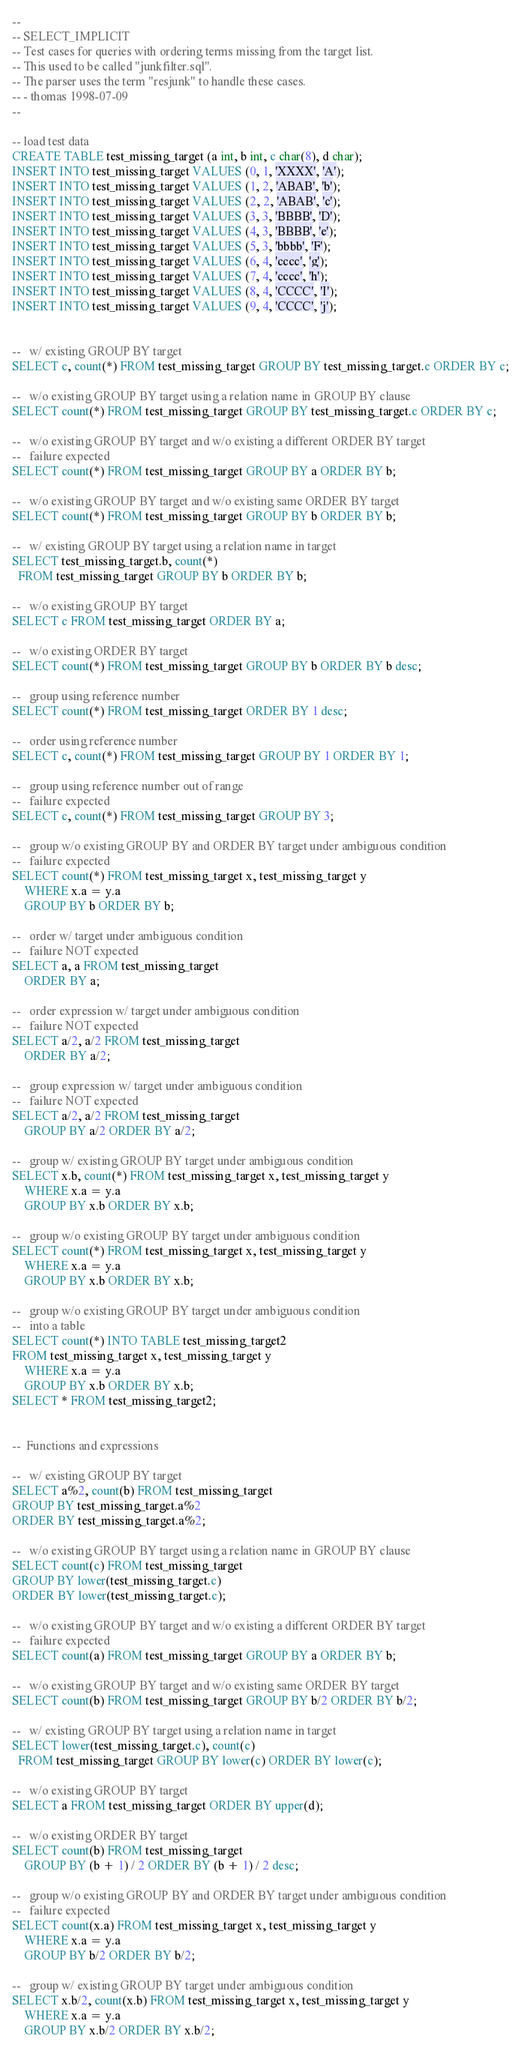Convert code to text. <code><loc_0><loc_0><loc_500><loc_500><_SQL_>--
-- SELECT_IMPLICIT
-- Test cases for queries with ordering terms missing from the target list.
-- This used to be called "junkfilter.sql".
-- The parser uses the term "resjunk" to handle these cases.
-- - thomas 1998-07-09
--

-- load test data
CREATE TABLE test_missing_target (a int, b int, c char(8), d char);
INSERT INTO test_missing_target VALUES (0, 1, 'XXXX', 'A');
INSERT INTO test_missing_target VALUES (1, 2, 'ABAB', 'b');
INSERT INTO test_missing_target VALUES (2, 2, 'ABAB', 'c');
INSERT INTO test_missing_target VALUES (3, 3, 'BBBB', 'D');
INSERT INTO test_missing_target VALUES (4, 3, 'BBBB', 'e');
INSERT INTO test_missing_target VALUES (5, 3, 'bbbb', 'F');
INSERT INTO test_missing_target VALUES (6, 4, 'cccc', 'g');
INSERT INTO test_missing_target VALUES (7, 4, 'cccc', 'h');
INSERT INTO test_missing_target VALUES (8, 4, 'CCCC', 'I');
INSERT INTO test_missing_target VALUES (9, 4, 'CCCC', 'j');


--   w/ existing GROUP BY target
SELECT c, count(*) FROM test_missing_target GROUP BY test_missing_target.c ORDER BY c;

--   w/o existing GROUP BY target using a relation name in GROUP BY clause
SELECT count(*) FROM test_missing_target GROUP BY test_missing_target.c ORDER BY c;

--   w/o existing GROUP BY target and w/o existing a different ORDER BY target
--   failure expected
SELECT count(*) FROM test_missing_target GROUP BY a ORDER BY b;

--   w/o existing GROUP BY target and w/o existing same ORDER BY target
SELECT count(*) FROM test_missing_target GROUP BY b ORDER BY b;

--   w/ existing GROUP BY target using a relation name in target
SELECT test_missing_target.b, count(*)
  FROM test_missing_target GROUP BY b ORDER BY b;

--   w/o existing GROUP BY target
SELECT c FROM test_missing_target ORDER BY a;

--   w/o existing ORDER BY target
SELECT count(*) FROM test_missing_target GROUP BY b ORDER BY b desc;

--   group using reference number
SELECT count(*) FROM test_missing_target ORDER BY 1 desc;

--   order using reference number
SELECT c, count(*) FROM test_missing_target GROUP BY 1 ORDER BY 1;

--   group using reference number out of range
--   failure expected
SELECT c, count(*) FROM test_missing_target GROUP BY 3;

--   group w/o existing GROUP BY and ORDER BY target under ambiguous condition
--   failure expected
SELECT count(*) FROM test_missing_target x, test_missing_target y
	WHERE x.a = y.a
	GROUP BY b ORDER BY b;

--   order w/ target under ambiguous condition
--   failure NOT expected
SELECT a, a FROM test_missing_target
	ORDER BY a;

--   order expression w/ target under ambiguous condition
--   failure NOT expected
SELECT a/2, a/2 FROM test_missing_target
	ORDER BY a/2;

--   group expression w/ target under ambiguous condition
--   failure NOT expected
SELECT a/2, a/2 FROM test_missing_target
	GROUP BY a/2 ORDER BY a/2;

--   group w/ existing GROUP BY target under ambiguous condition
SELECT x.b, count(*) FROM test_missing_target x, test_missing_target y
	WHERE x.a = y.a
	GROUP BY x.b ORDER BY x.b;

--   group w/o existing GROUP BY target under ambiguous condition
SELECT count(*) FROM test_missing_target x, test_missing_target y
	WHERE x.a = y.a
	GROUP BY x.b ORDER BY x.b;

--   group w/o existing GROUP BY target under ambiguous condition
--   into a table
SELECT count(*) INTO TABLE test_missing_target2
FROM test_missing_target x, test_missing_target y
	WHERE x.a = y.a
	GROUP BY x.b ORDER BY x.b;
SELECT * FROM test_missing_target2;


--  Functions and expressions

--   w/ existing GROUP BY target
SELECT a%2, count(b) FROM test_missing_target
GROUP BY test_missing_target.a%2
ORDER BY test_missing_target.a%2;

--   w/o existing GROUP BY target using a relation name in GROUP BY clause
SELECT count(c) FROM test_missing_target
GROUP BY lower(test_missing_target.c)
ORDER BY lower(test_missing_target.c);

--   w/o existing GROUP BY target and w/o existing a different ORDER BY target
--   failure expected
SELECT count(a) FROM test_missing_target GROUP BY a ORDER BY b;

--   w/o existing GROUP BY target and w/o existing same ORDER BY target
SELECT count(b) FROM test_missing_target GROUP BY b/2 ORDER BY b/2;

--   w/ existing GROUP BY target using a relation name in target
SELECT lower(test_missing_target.c), count(c)
  FROM test_missing_target GROUP BY lower(c) ORDER BY lower(c);

--   w/o existing GROUP BY target
SELECT a FROM test_missing_target ORDER BY upper(d);

--   w/o existing ORDER BY target
SELECT count(b) FROM test_missing_target
	GROUP BY (b + 1) / 2 ORDER BY (b + 1) / 2 desc;

--   group w/o existing GROUP BY and ORDER BY target under ambiguous condition
--   failure expected
SELECT count(x.a) FROM test_missing_target x, test_missing_target y
	WHERE x.a = y.a
	GROUP BY b/2 ORDER BY b/2;

--   group w/ existing GROUP BY target under ambiguous condition
SELECT x.b/2, count(x.b) FROM test_missing_target x, test_missing_target y
	WHERE x.a = y.a
	GROUP BY x.b/2 ORDER BY x.b/2;
</code> 